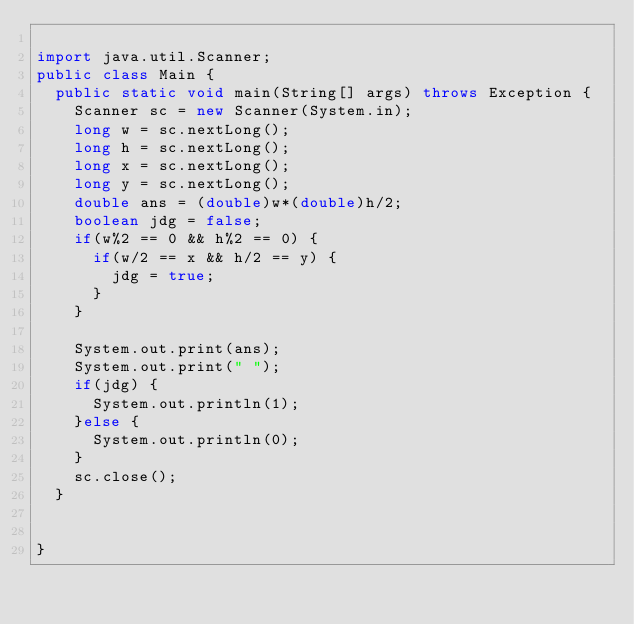Convert code to text. <code><loc_0><loc_0><loc_500><loc_500><_Java_>
import java.util.Scanner;
public class Main {
	public static void main(String[] args) throws Exception {
		Scanner sc = new Scanner(System.in);
		long w = sc.nextLong();
		long h = sc.nextLong();
		long x = sc.nextLong();
		long y = sc.nextLong();
		double ans = (double)w*(double)h/2;
		boolean jdg = false;
		if(w%2 == 0 && h%2 == 0) {
			if(w/2 == x && h/2 == y) {
				jdg = true;
			}
		}
		
		System.out.print(ans);
		System.out.print(" "); 
		if(jdg) {
			System.out.println(1);
		}else {
			System.out.println(0);
		}
		sc.close();
	}


}
</code> 